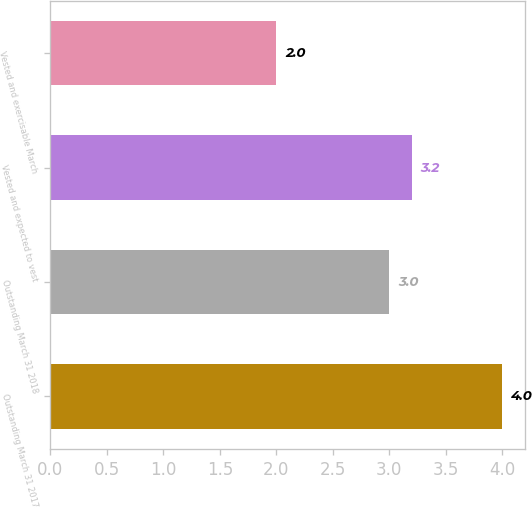<chart> <loc_0><loc_0><loc_500><loc_500><bar_chart><fcel>Outstanding March 31 2017<fcel>Outstanding March 31 2018<fcel>Vested and expected to vest<fcel>Vested and exercisable March<nl><fcel>4<fcel>3<fcel>3.2<fcel>2<nl></chart> 